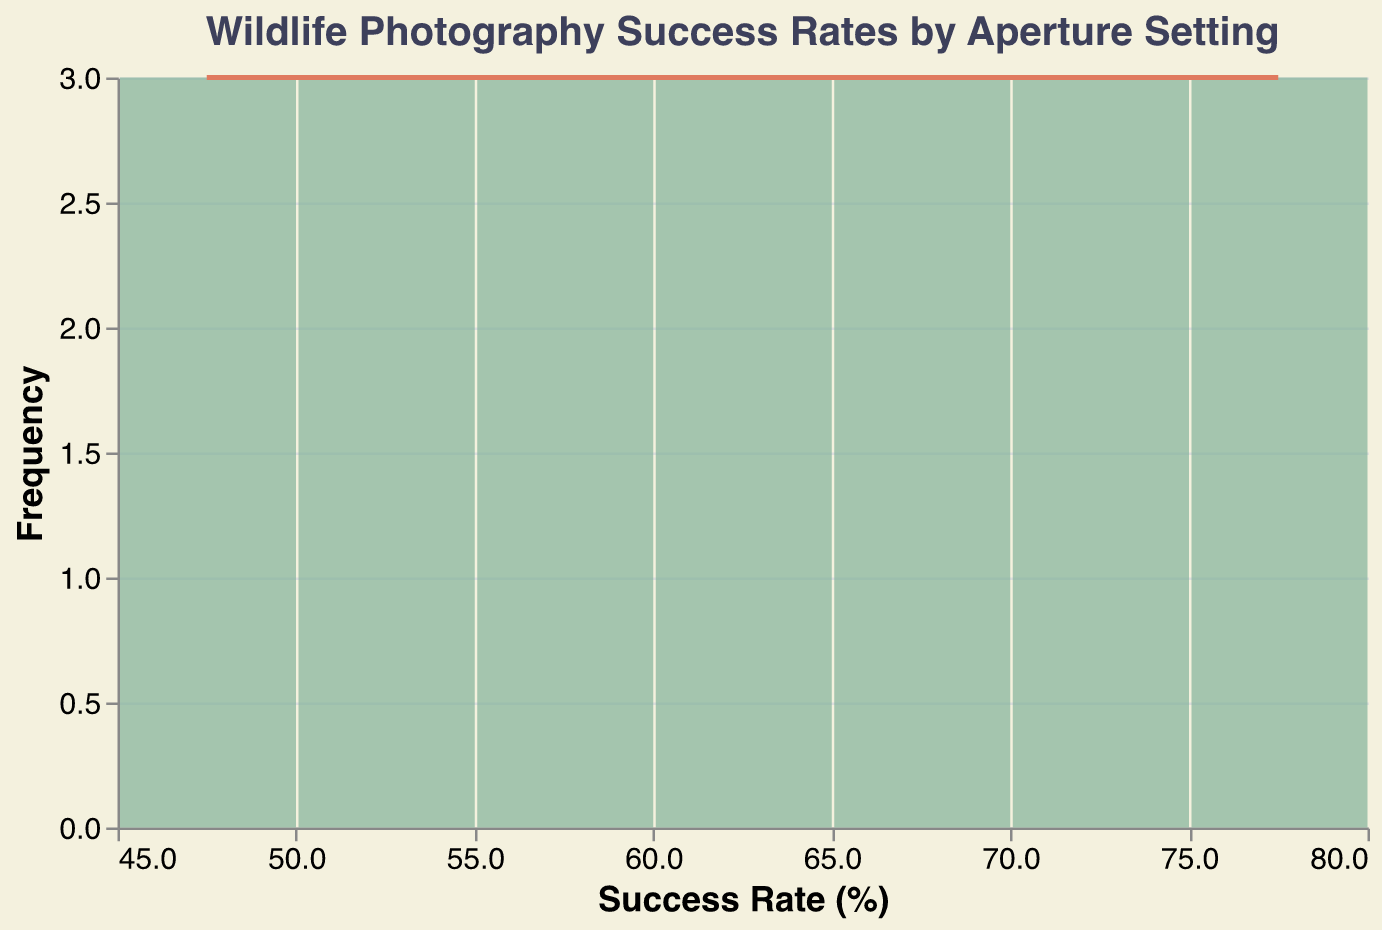What's the title of the figure? The title of the figure is located at the top and is often the largest and boldest text. It summarises what the figure is about.
Answer: Wildlife Photography Success Rates by Aperture Setting What does the x-axis represent? The x-axis represents the success rate in percentage, indicated by the labels and the axis title.
Answer: Success Rate (%) What does the y-axis represent? The y-axis represents the frequency of the different success rates, as indicated by the axis title.
Answer: Frequency What color is used for the bar chart? The color used for the bar chart is noticed by observing the bars themselves.
Answer: Green How many aperture settings are included in this data? By identifying the unique aperture settings in the data given and plotting, you can count them.
Answer: 7 Which success rate range has the highest frequency? By looking at the height of the bars, the highest bar shows the success rate range with the highest frequency.
Answer: 60-70% What is the approximate count at the peak frequency? By observing the highest point of the bars and the corresponding value on the y-axis, the count can be determined.
Answer: Around 8 How does the success rate change with increasing aperture settings from f/2.8 to f/22.0? Following the trend across aperture settings, observe the change in success rates to notice any increases or decreases. The figure shows that success rate decreases as the aperture setting increases.
Answer: Decreases Is there a smooth trendline over the bar chart? The figure shows a line chart overlaid on the bar chart to indicate trends, thus it's visible if there is a trendline.
Answer: Yes Does the bar chart show aggregated data? The figure's x-axis is binned and the y-axis shows frequencies, meaning bars likely represent aggregated counts of success rates within each bin.
Answer: Yes 